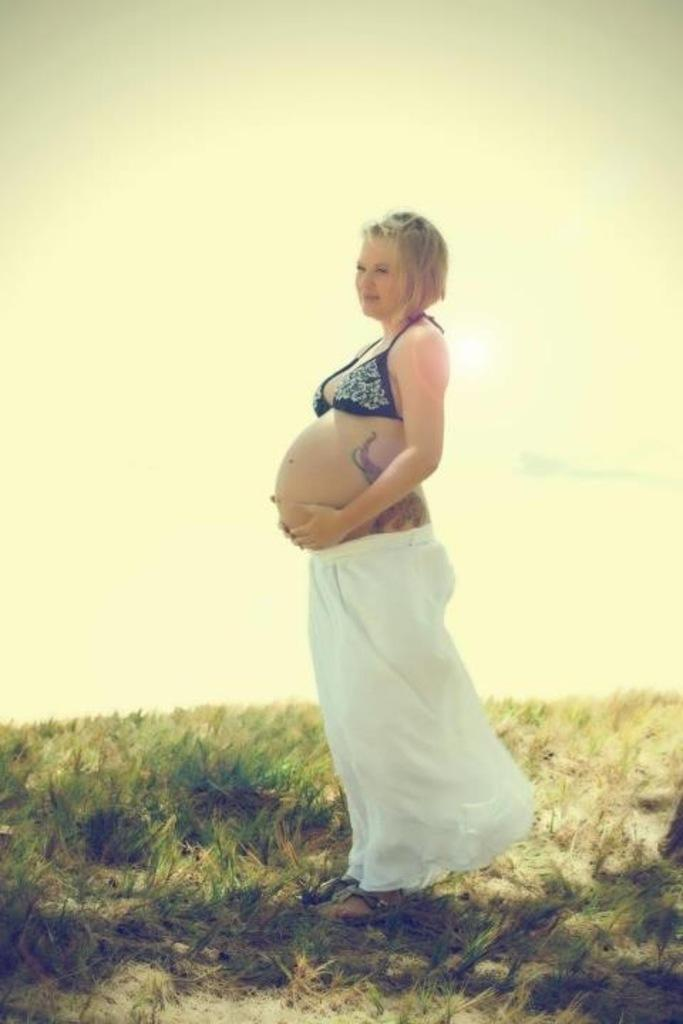What is the main subject of the image? There is a person standing in the image. What is the person wearing? The person is wearing a black and white dress. What type of natural environment is visible in the image? There is grass visible in the image. What part of the natural environment is visible in the image? The sky is visible in the image. What type of insurance policy does the person have in the image? There is no information about insurance policies in the image; it only shows a person standing in a grassy area with the sky visible. 